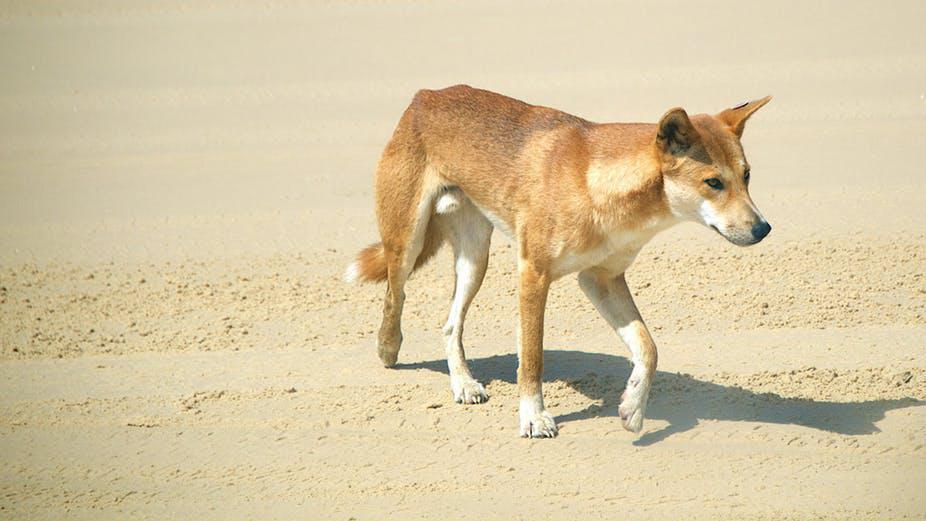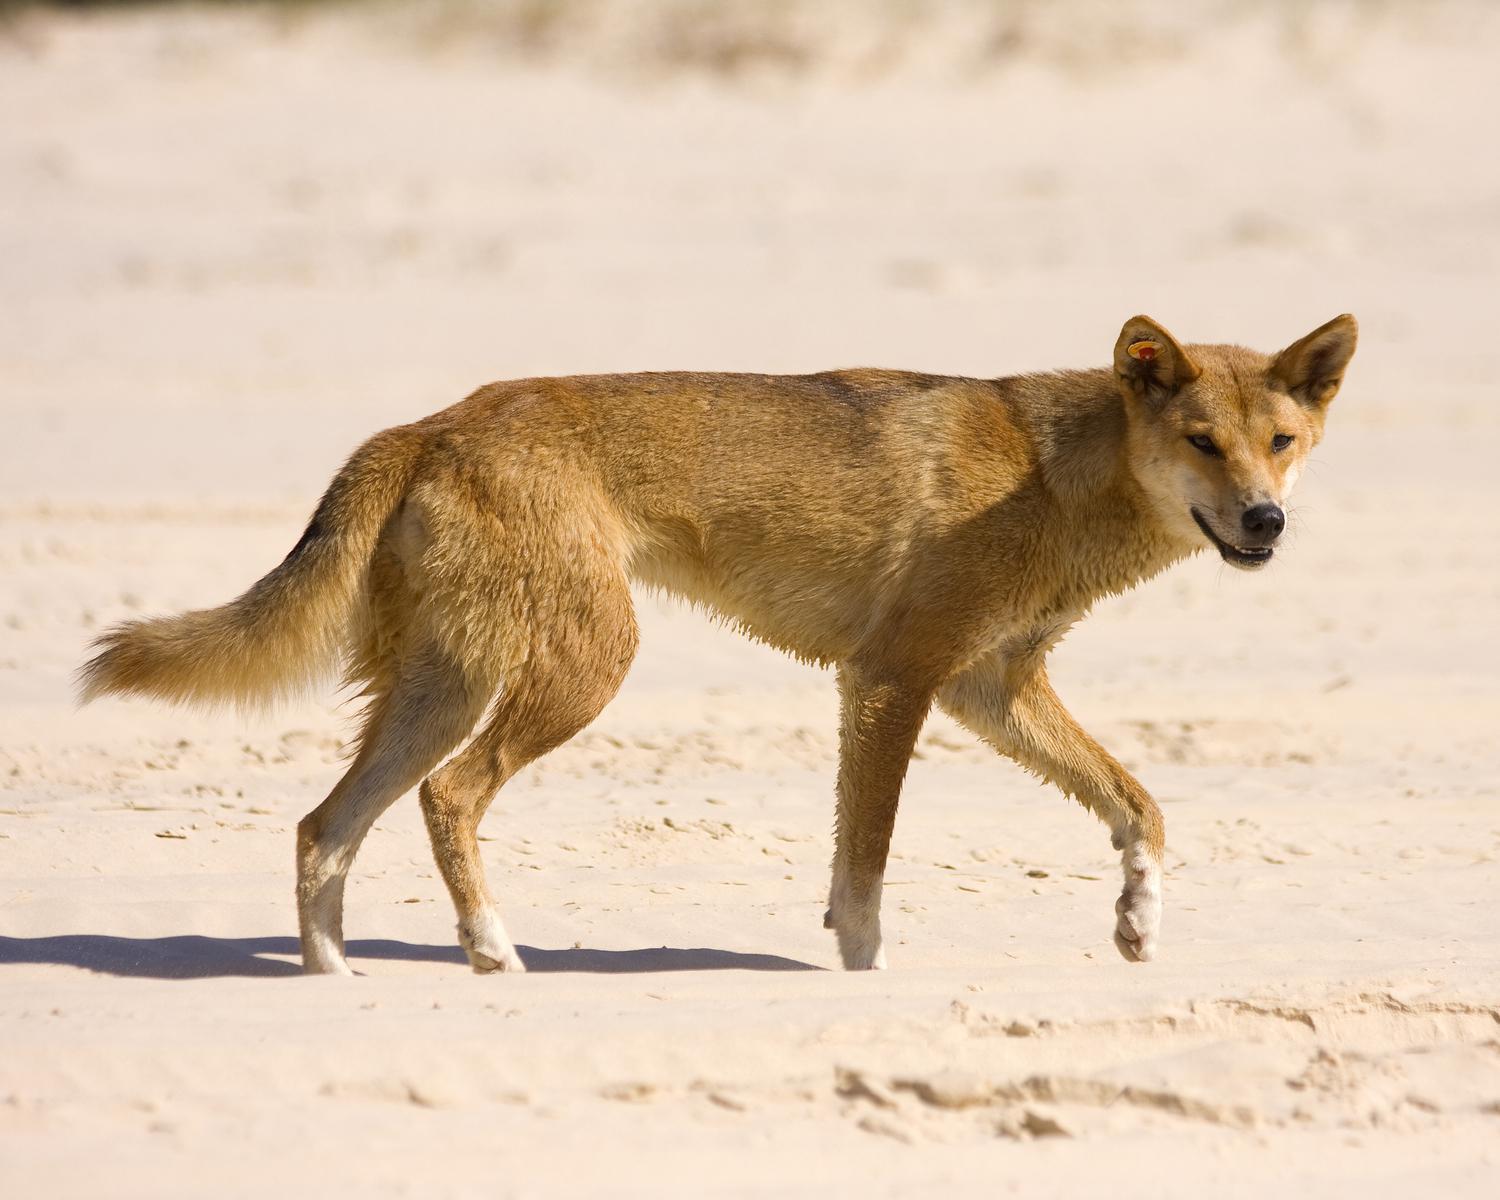The first image is the image on the left, the second image is the image on the right. Evaluate the accuracy of this statement regarding the images: "A wild dog is standing near a half eaten shark in the image on the right.". Is it true? Answer yes or no. No. 